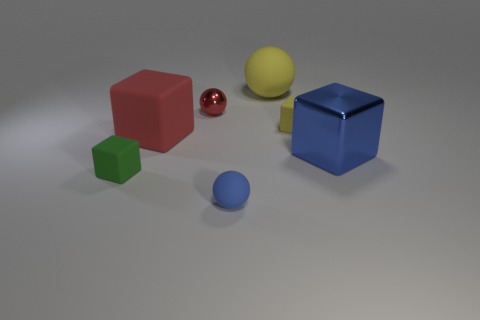Subtract all yellow matte cubes. How many cubes are left? 3 Subtract all red balls. How many balls are left? 2 Subtract all blocks. How many objects are left? 3 Subtract 1 blocks. How many blocks are left? 3 Add 1 cylinders. How many objects exist? 8 Subtract all purple cubes. Subtract all yellow cylinders. How many cubes are left? 4 Subtract all tiny metal objects. Subtract all big blue shiny cubes. How many objects are left? 5 Add 3 green matte cubes. How many green matte cubes are left? 4 Add 4 red shiny objects. How many red shiny objects exist? 5 Subtract 1 red balls. How many objects are left? 6 